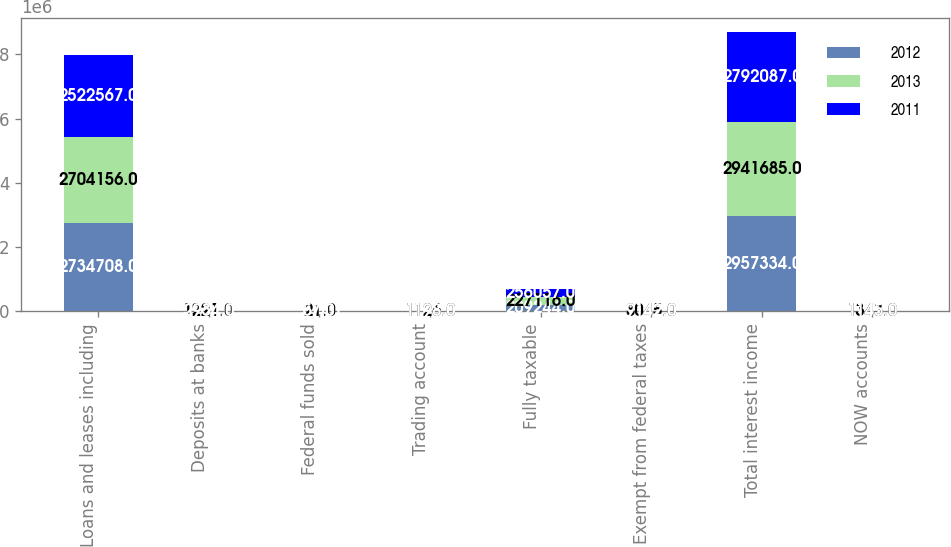Convert chart to OTSL. <chart><loc_0><loc_0><loc_500><loc_500><stacked_bar_chart><ecel><fcel>Loans and leases including<fcel>Deposits at banks<fcel>Federal funds sold<fcel>Trading account<fcel>Fully taxable<fcel>Exempt from federal taxes<fcel>Total interest income<fcel>NOW accounts<nl><fcel>2012<fcel>2.73471e+06<fcel>5201<fcel>104<fcel>1265<fcel>209244<fcel>6802<fcel>2.95733e+06<fcel>1287<nl><fcel>2013<fcel>2.70416e+06<fcel>1221<fcel>21<fcel>1126<fcel>227116<fcel>8045<fcel>2.94168e+06<fcel>1343<nl><fcel>2011<fcel>2.52257e+06<fcel>2934<fcel>57<fcel>1198<fcel>256057<fcel>9142<fcel>2.79209e+06<fcel>1145<nl></chart> 